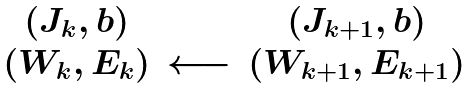<formula> <loc_0><loc_0><loc_500><loc_500>\begin{array} { c c c } ( J _ { k } , b ) & & ( J _ { k + 1 } , b ) \\ ( W _ { k } , E _ { k } ) & \longleftarrow & ( W _ { k + 1 } , E _ { k + 1 } ) \end{array}</formula> 